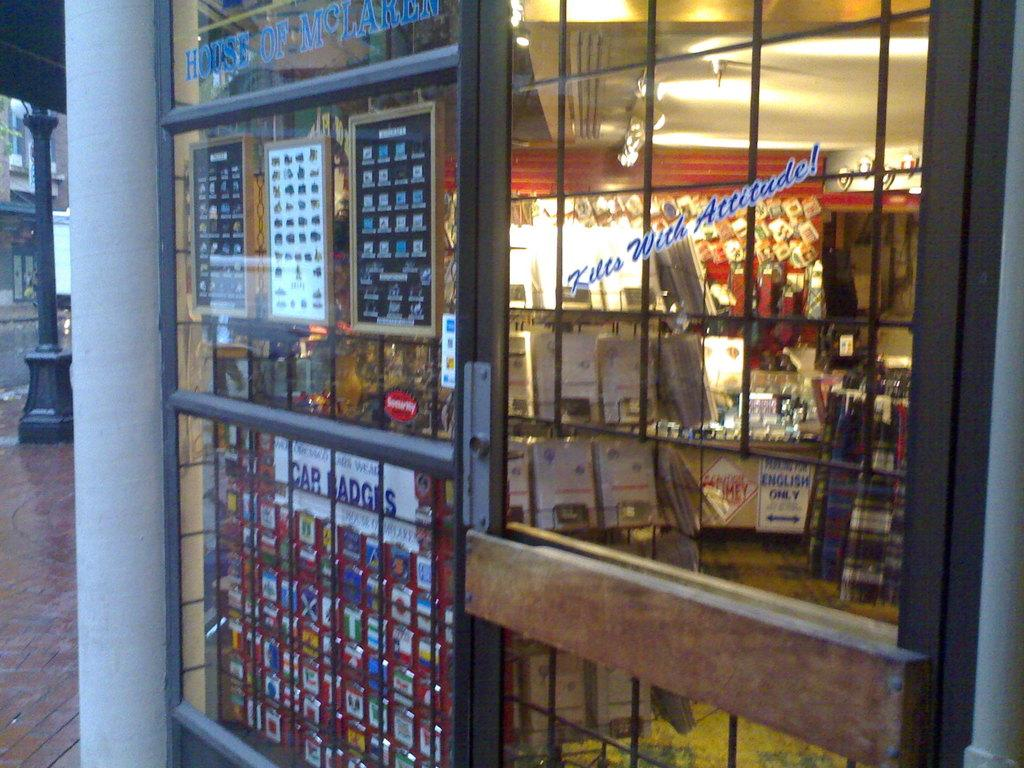<image>
Create a compact narrative representing the image presented. A window to the inside the plaid fabric shop has a sign that reads "Kilts with Attitude!" 